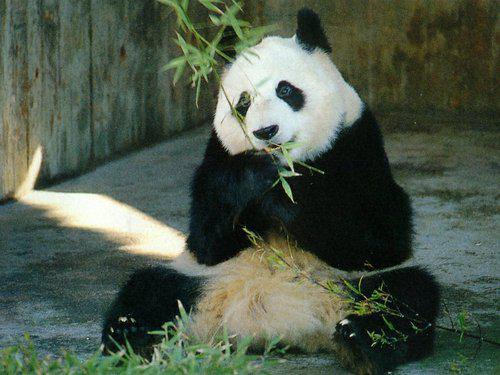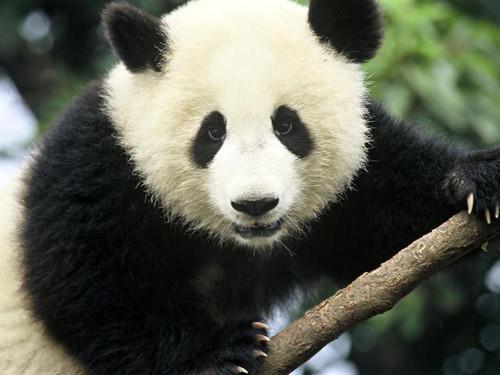The first image is the image on the left, the second image is the image on the right. For the images displayed, is the sentence "The panda on the left is nibbling a green stick without leaves on it." factually correct? Answer yes or no. No. 